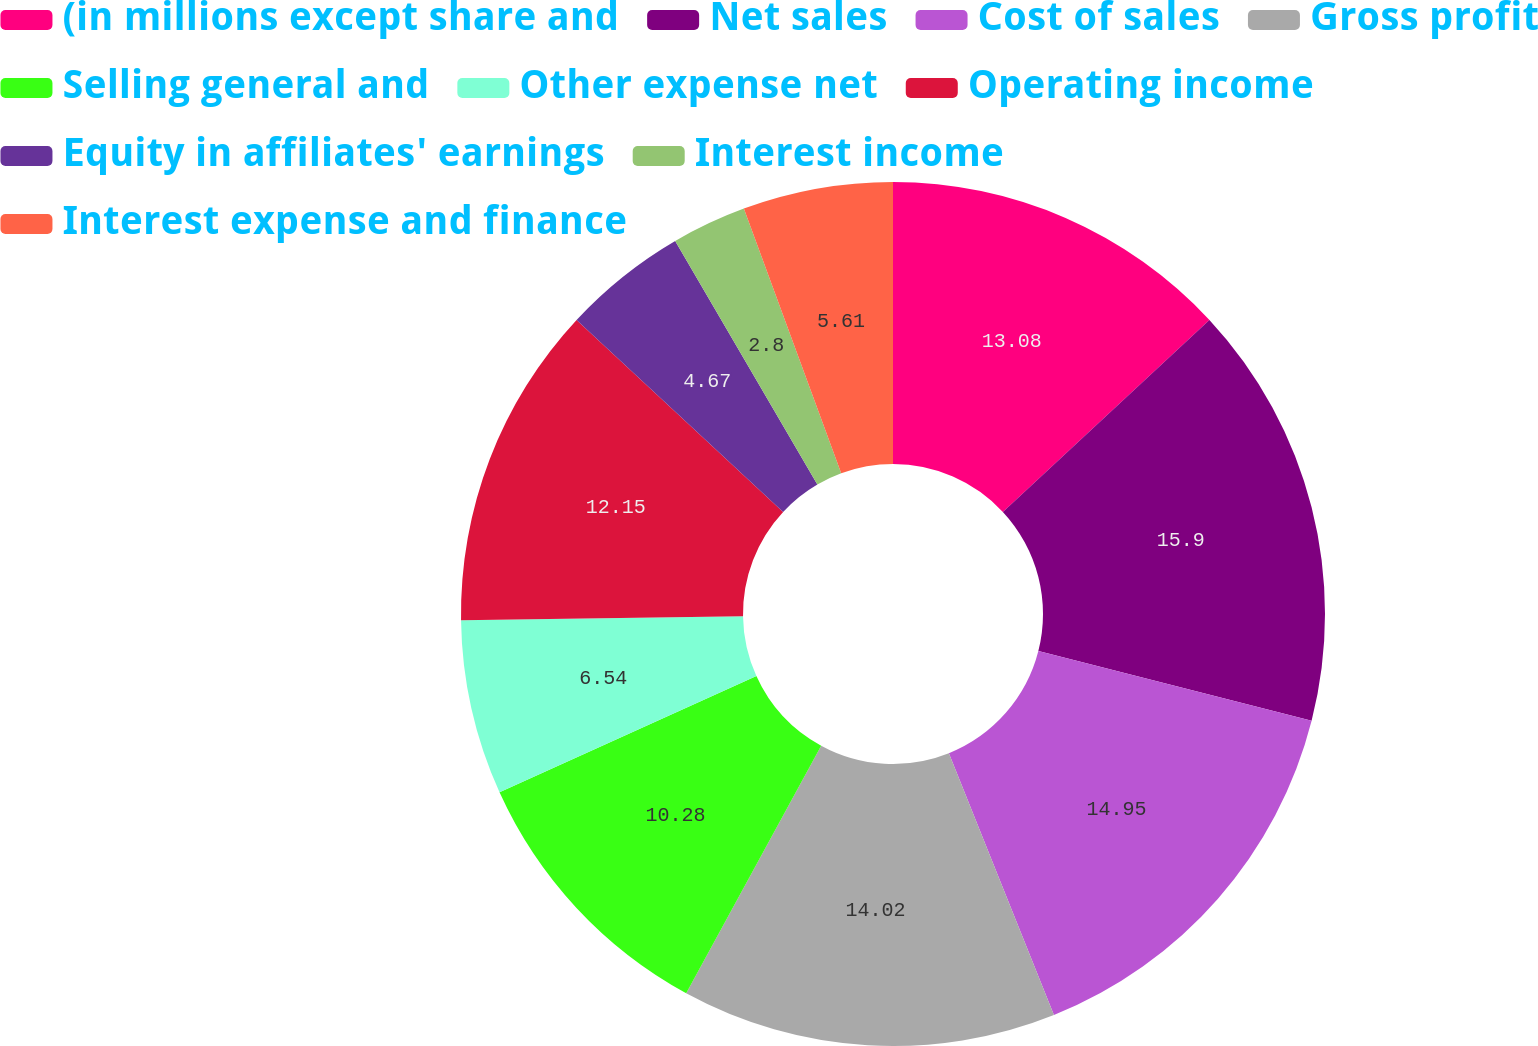Convert chart. <chart><loc_0><loc_0><loc_500><loc_500><pie_chart><fcel>(in millions except share and<fcel>Net sales<fcel>Cost of sales<fcel>Gross profit<fcel>Selling general and<fcel>Other expense net<fcel>Operating income<fcel>Equity in affiliates' earnings<fcel>Interest income<fcel>Interest expense and finance<nl><fcel>13.08%<fcel>15.89%<fcel>14.95%<fcel>14.02%<fcel>10.28%<fcel>6.54%<fcel>12.15%<fcel>4.67%<fcel>2.8%<fcel>5.61%<nl></chart> 